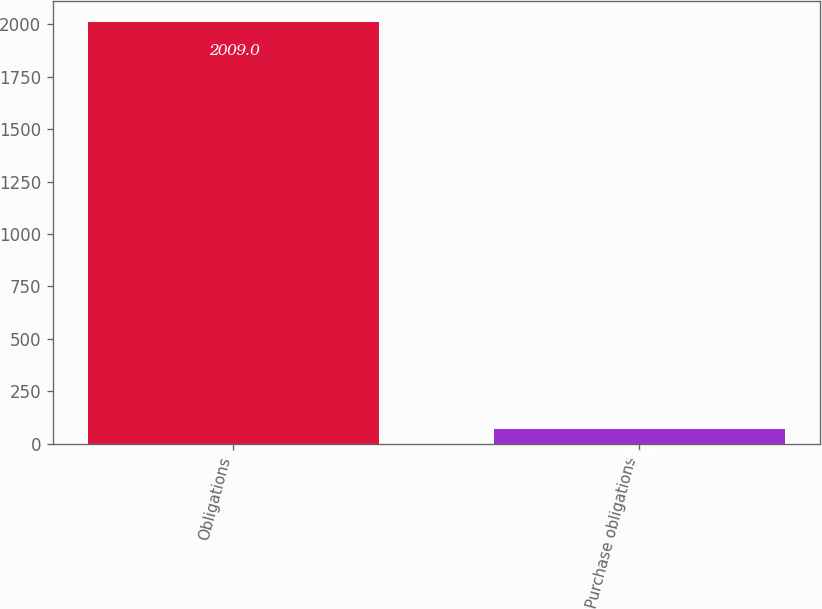Convert chart. <chart><loc_0><loc_0><loc_500><loc_500><bar_chart><fcel>Obligations<fcel>Purchase obligations<nl><fcel>2009<fcel>72.3<nl></chart> 